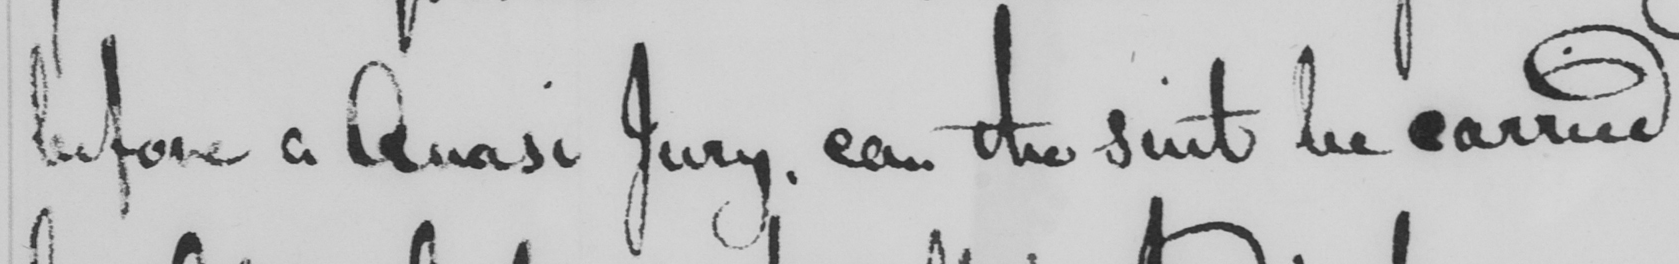Please provide the text content of this handwritten line. before a Quasi Jury , can the suit be carried 